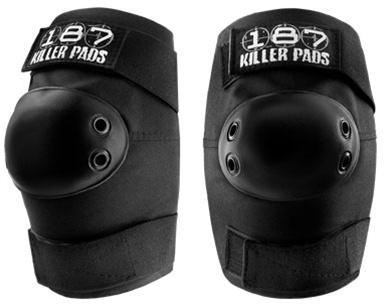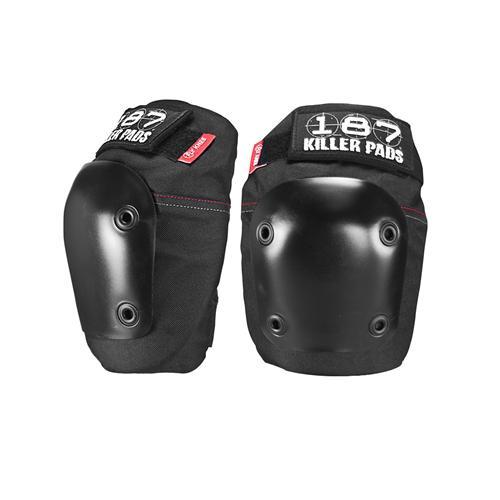The first image is the image on the left, the second image is the image on the right. Evaluate the accuracy of this statement regarding the images: "Each image contains a pair of black knee pads, and one image features a pair of knee pads with black and white print on the tops and bottoms.". Is it true? Answer yes or no. No. The first image is the image on the left, the second image is the image on the right. For the images displayed, is the sentence "One pair of pads has visible red tags, and the other pair does not." factually correct? Answer yes or no. Yes. 